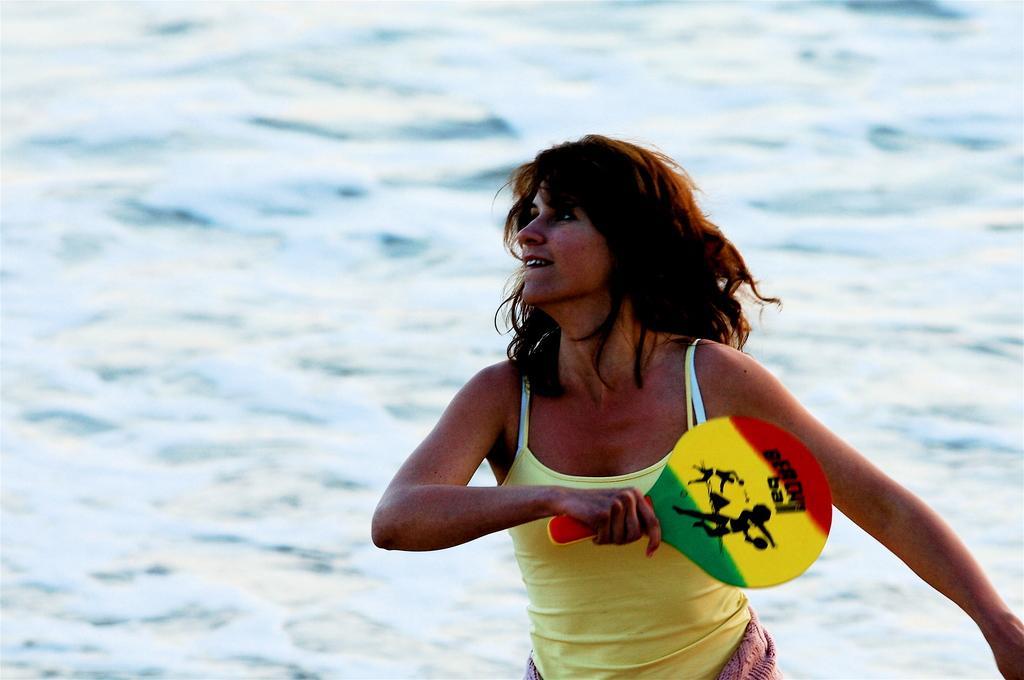How would you summarize this image in a sentence or two? In this image I can see a woman and I can see she is wearing yellow colour dress. I can also see she is holding a racket. 